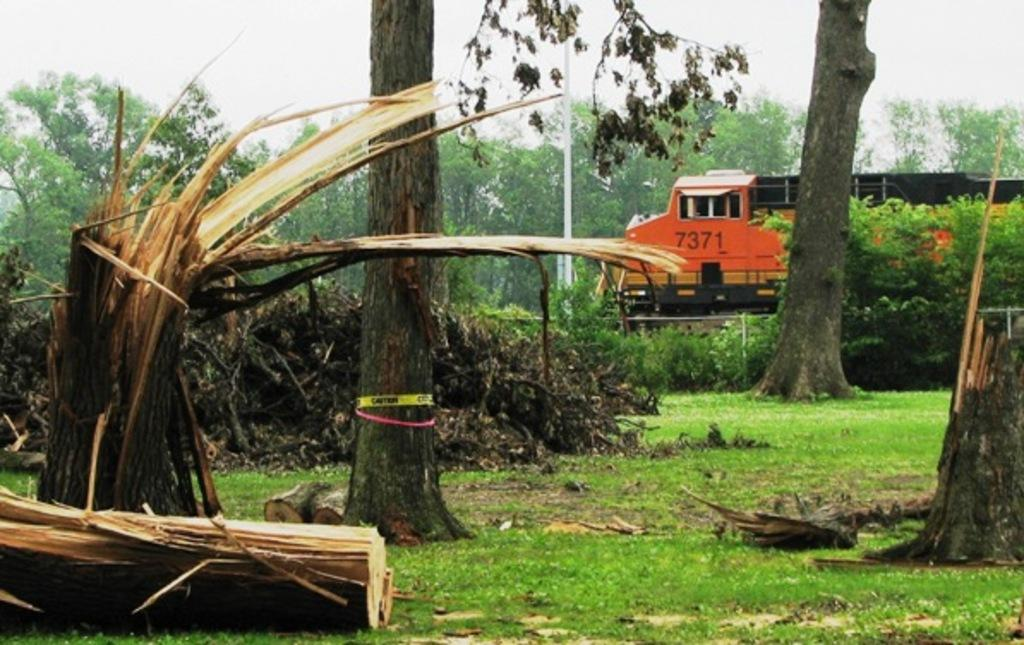What type of vegetation is present on the ground in the image? There is grass on the ground in the image. What other wooden objects can be seen in the image? There are wooden logs visible in the image. What are the tree trunks used for in the image? The tree trunks are likely used as support or decoration in the image. What can be seen in the background of the image? Trees and the sky are visible in the background of the image. What type of vehicle is present in the image? There is a vehicle in the image, but its specific type is not mentioned in the facts. How many babies are crying in the image? There are no babies or crying sounds present in the image. What type of musical instrument is being played in the image? There is no musical instrument or indication of music being played in the image. 